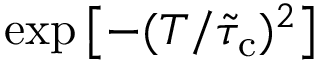Convert formula to latex. <formula><loc_0><loc_0><loc_500><loc_500>\exp \left [ - ( T / \tilde { \tau } _ { c } ) ^ { 2 } \right ]</formula> 